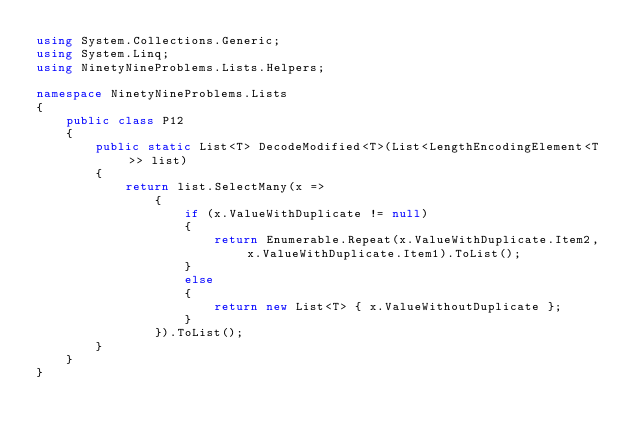<code> <loc_0><loc_0><loc_500><loc_500><_C#_>using System.Collections.Generic;
using System.Linq;
using NinetyNineProblems.Lists.Helpers;

namespace NinetyNineProblems.Lists
{
    public class P12
    {
        public static List<T> DecodeModified<T>(List<LengthEncodingElement<T>> list)
        {
            return list.SelectMany(x =>
                {
                    if (x.ValueWithDuplicate != null)
                    {
                        return Enumerable.Repeat(x.ValueWithDuplicate.Item2, x.ValueWithDuplicate.Item1).ToList();
                    }
                    else
                    {
                        return new List<T> { x.ValueWithoutDuplicate };
                    }
                }).ToList();
        }
    }
}</code> 